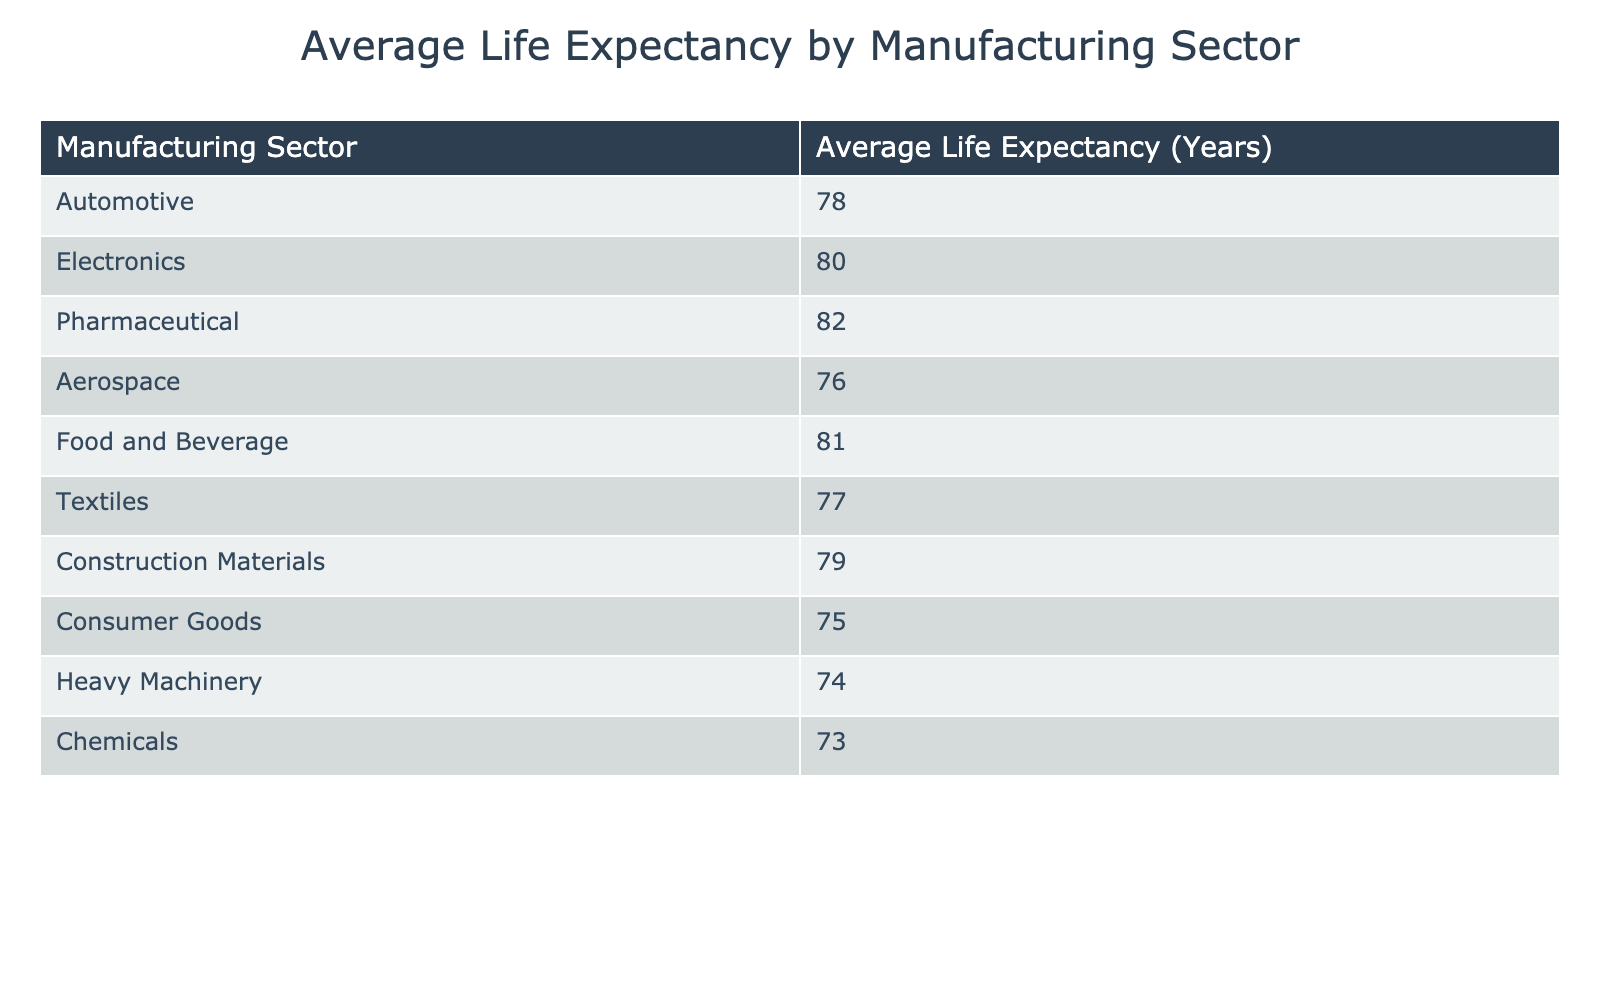What is the average life expectancy for the pharmaceutical sector? According to the table, the average life expectancy for the pharmaceutical sector is specified directly as 82 years.
Answer: 82 Which manufacturing sector has the lowest average life expectancy? By examining the table, the sector with the lowest average life expectancy is chemicals, which is listed as having 73 years.
Answer: Chemicals What is the average life expectancy of the automotive and aerospace sectors combined? To find the average life expectancy of the automotive (78 years) and aerospace (76 years) sectors, we add the two values (78 + 76 = 154) and then divide by 2, which results in an average of 77 years.
Answer: 77 Is the average life expectancy of the electronics sector greater than that of the heavy machinery sector? The table shows that the average life expectancy for electronics is 80 years and for heavy machinery is 74 years, meaning electronics does have a greater life expectancy. Therefore, the statement is true.
Answer: Yes What is the difference in average life expectancy between the food and beverage sector and the textiles sector? The average life expectancy for the food and beverage sector is 81 years, while for the textiles sector it is 77 years. To find the difference, we subtract 77 from 81 (81 - 77 = 4), indicating that food and beverage has 4 years more average life expectancy than textiles.
Answer: 4 How many sectors have an average life expectancy above 80 years? Looking at the table, the sectors with an average life expectancy above 80 years are pharmaceuticals (82), and food and beverage (81). This results in a total of 3 sectors (pharmaceuticals, electronics, and food and beverage) that fit this criterion. Therefore, the total count is 3.
Answer: 3 What is the average life expectancy across all sectors listed in the table? To find the overall average, we sum the life expectancies of all sectors: (78 + 80 + 82 + 76 + 81 + 77 + 79 + 75 + 74 + 73 =  784). Then, we divide by the number of sectors (10), resulting in an average of 78.4 years across all sectors.
Answer: 78.4 Are there more sectors with an average life expectancy of less than 78 years than those with 78 years or more? The sectors with less than 78 years of life expectancy are chemicals (73), heavy machinery (74), and consumer goods (75), totaling 3. The sectors with 78 years or more are automotive (78), electronics (80), pharmaceuticals (82), aerospace (76), food and beverage (81), textiles (77), and construction materials (79), totaling 7. Since 3 is less than 7, the statement is false.
Answer: No 